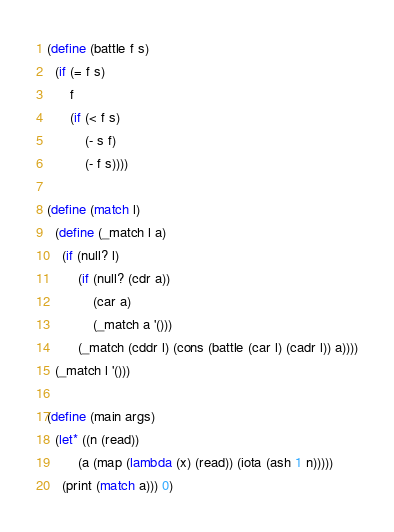<code> <loc_0><loc_0><loc_500><loc_500><_Scheme_>(define (battle f s)
  (if (= f s)
      f
      (if (< f s)
          (- s f)
          (- f s))))

(define (match l)
  (define (_match l a)
    (if (null? l)
        (if (null? (cdr a))
            (car a)
            (_match a '()))
        (_match (cddr l) (cons (battle (car l) (cadr l)) a))))
  (_match l '()))

(define (main args)
  (let* ((n (read))
        (a (map (lambda (x) (read)) (iota (ash 1 n)))))
    (print (match a))) 0)

</code> 